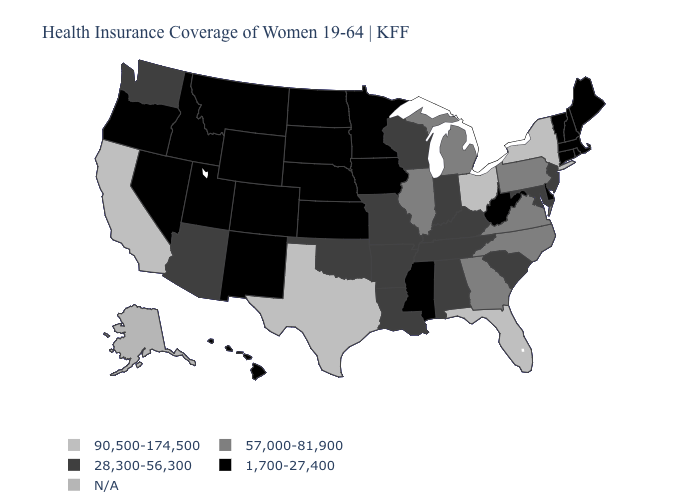Name the states that have a value in the range 57,000-81,900?
Give a very brief answer. Georgia, Illinois, Michigan, North Carolina, Pennsylvania, Virginia. What is the value of Missouri?
Give a very brief answer. 28,300-56,300. What is the value of Louisiana?
Give a very brief answer. 28,300-56,300. What is the highest value in the USA?
Concise answer only. 90,500-174,500. What is the highest value in the West ?
Write a very short answer. 90,500-174,500. What is the highest value in the West ?
Short answer required. 90,500-174,500. How many symbols are there in the legend?
Answer briefly. 5. What is the value of South Carolina?
Concise answer only. 28,300-56,300. What is the highest value in the MidWest ?
Be succinct. 90,500-174,500. Name the states that have a value in the range 90,500-174,500?
Be succinct. California, Florida, New York, Ohio, Texas. What is the value of Delaware?
Be succinct. 1,700-27,400. Name the states that have a value in the range 1,700-27,400?
Write a very short answer. Colorado, Connecticut, Delaware, Hawaii, Idaho, Iowa, Kansas, Maine, Massachusetts, Minnesota, Mississippi, Montana, Nebraska, Nevada, New Hampshire, New Mexico, North Dakota, Oregon, Rhode Island, South Dakota, Utah, Vermont, West Virginia, Wyoming. What is the value of North Dakota?
Keep it brief. 1,700-27,400. Is the legend a continuous bar?
Be succinct. No. Among the states that border Idaho , does Nevada have the lowest value?
Answer briefly. Yes. 